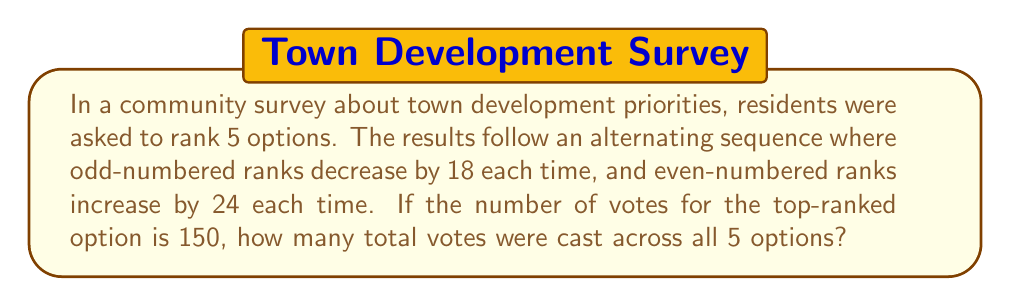Show me your answer to this math problem. Let's approach this step-by-step:

1) We're told that the sequence alternates, with odd ranks decreasing by 18 and even ranks increasing by 24.

2) Let's write out the sequence:
   1st rank: 150
   2nd rank: $150 + 24 = 174$
   3rd rank: $150 - 18 = 132$
   4th rank: $174 + 24 = 198$
   5th rank: $132 - 18 = 114$

3) The sequence can be represented as:
   $a_1 = 150$
   $a_2 = a_1 + 24 = 174$
   $a_3 = a_1 - 18 = 132$
   $a_4 = a_2 + 24 = 198$
   $a_5 = a_3 - 18 = 114$

4) To find the total votes, we need to sum all these values:

   $\text{Total} = a_1 + a_2 + a_3 + a_4 + a_5$

5) Substituting the values:

   $\text{Total} = 150 + 174 + 132 + 198 + 114$

6) Adding these up:

   $\text{Total} = 768$

Therefore, the total number of votes cast across all 5 options is 768.
Answer: 768 